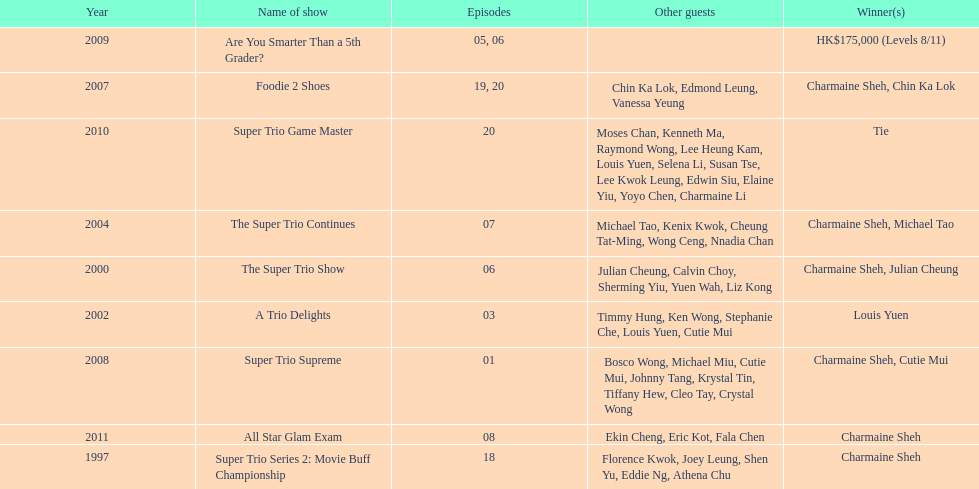Could you parse the entire table? {'header': ['Year', 'Name of show', 'Episodes', 'Other guests', 'Winner(s)'], 'rows': [['2009', 'Are You Smarter Than a 5th Grader?', '05, 06', '', 'HK$175,000 (Levels 8/11)'], ['2007', 'Foodie 2 Shoes', '19, 20', 'Chin Ka Lok, Edmond Leung, Vanessa Yeung', 'Charmaine Sheh, Chin Ka Lok'], ['2010', 'Super Trio Game Master', '20', 'Moses Chan, Kenneth Ma, Raymond Wong, Lee Heung Kam, Louis Yuen, Selena Li, Susan Tse, Lee Kwok Leung, Edwin Siu, Elaine Yiu, Yoyo Chen, Charmaine Li', 'Tie'], ['2004', 'The Super Trio Continues', '07', 'Michael Tao, Kenix Kwok, Cheung Tat-Ming, Wong Ceng, Nnadia Chan', 'Charmaine Sheh, Michael Tao'], ['2000', 'The Super Trio Show', '06', 'Julian Cheung, Calvin Choy, Sherming Yiu, Yuen Wah, Liz Kong', 'Charmaine Sheh, Julian Cheung'], ['2002', 'A Trio Delights', '03', 'Timmy Hung, Ken Wong, Stephanie Che, Louis Yuen, Cutie Mui', 'Louis Yuen'], ['2008', 'Super Trio Supreme', '01', 'Bosco Wong, Michael Miu, Cutie Mui, Johnny Tang, Krystal Tin, Tiffany Hew, Cleo Tay, Crystal Wong', 'Charmaine Sheh, Cutie Mui'], ['2011', 'All Star Glam Exam', '08', 'Ekin Cheng, Eric Kot, Fala Chen', 'Charmaine Sheh'], ['1997', 'Super Trio Series 2: Movie Buff Championship', '18', 'Florence Kwok, Joey Leung, Shen Yu, Eddie Ng, Athena Chu', 'Charmaine Sheh']]} How many times has charmaine sheh won on a variety show? 6. 